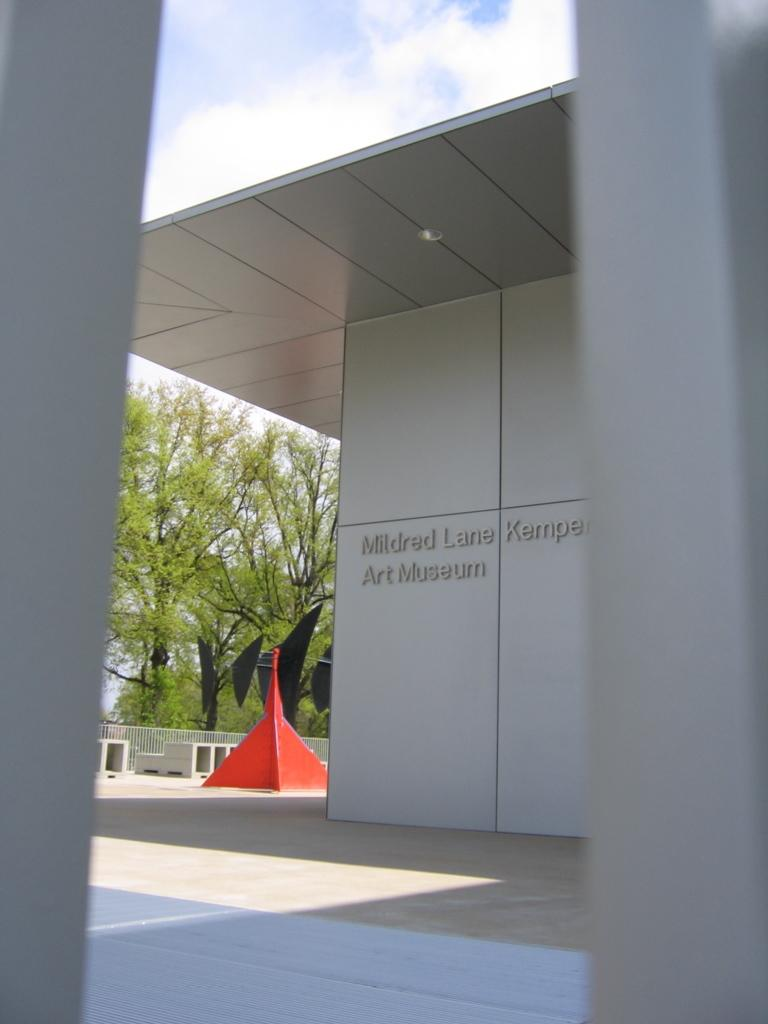What is written on the wall of the building in the image? There is a building with a name on the wall in the image. What color is the prominent object in the background? There is a red color object in the background. What can be seen in the background that might be related to safety or accessibility? There is railing in the background. What type of natural elements are visible in the background? Trees are visible in the background. What is the condition of the sky in the image? The sky with clouds is visible in the background. What type of pencil can be seen in the image? There is no pencil present in the image. How does the bell sound in the image? There is no bell present in the image, so it is not possible to determine its sound. 